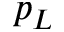<formula> <loc_0><loc_0><loc_500><loc_500>p _ { L }</formula> 